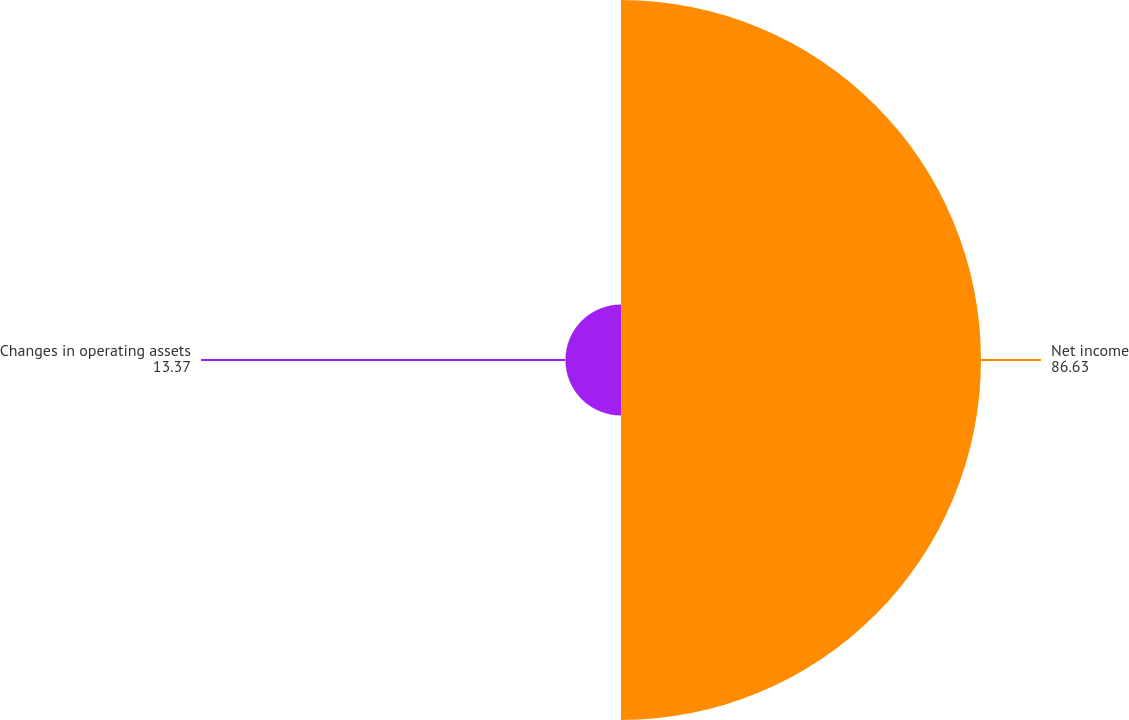<chart> <loc_0><loc_0><loc_500><loc_500><pie_chart><fcel>Net income<fcel>Changes in operating assets<nl><fcel>86.63%<fcel>13.37%<nl></chart> 